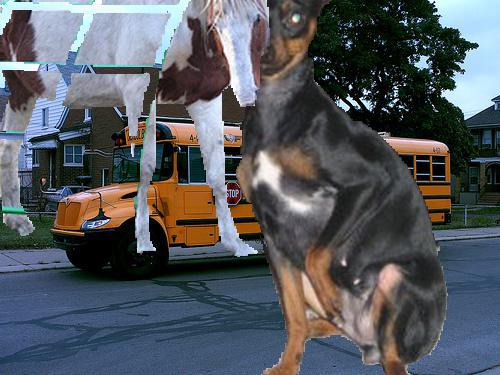What time of day does this image seem to reflect? The bright lighting and clear visibility suggest it's likely daytime. 